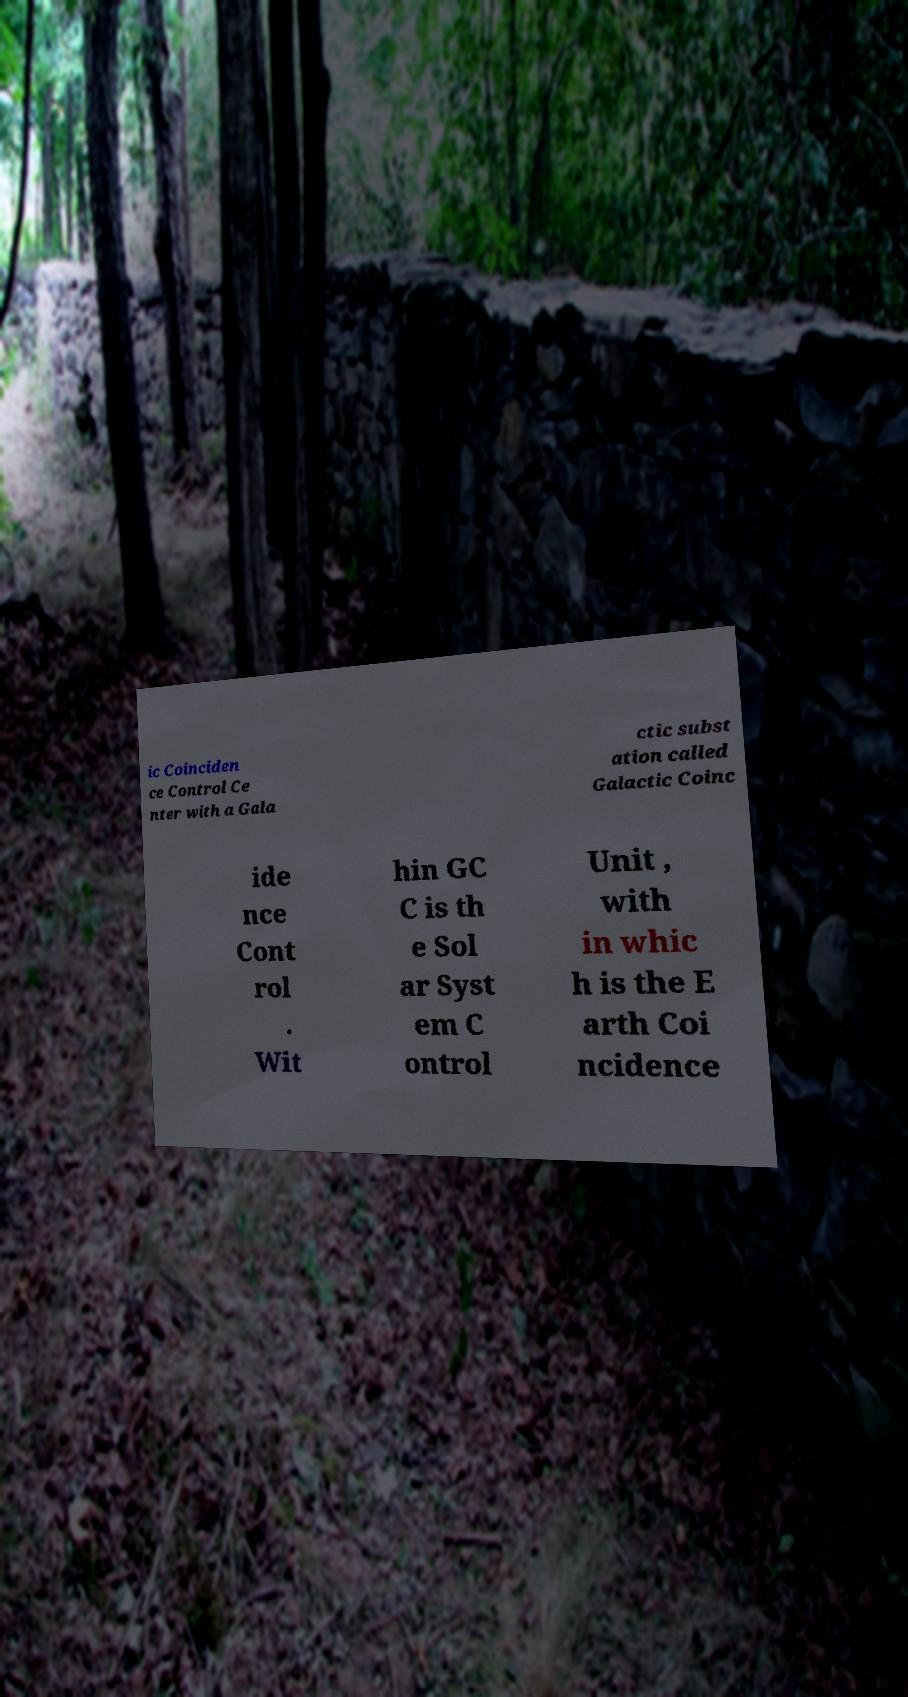Can you accurately transcribe the text from the provided image for me? ic Coinciden ce Control Ce nter with a Gala ctic subst ation called Galactic Coinc ide nce Cont rol . Wit hin GC C is th e Sol ar Syst em C ontrol Unit , with in whic h is the E arth Coi ncidence 